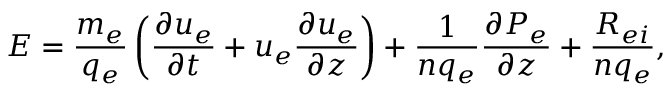<formula> <loc_0><loc_0><loc_500><loc_500>E = \frac { m _ { e } } { q _ { e } } \left ( \frac { \partial u _ { e } } { \partial t } + u _ { e } \frac { \partial u _ { e } } { \partial z } \right ) + \frac { 1 } { n q _ { e } } \frac { \partial P _ { e } } { \partial z } + \frac { R _ { e i } } { n q _ { e } } ,</formula> 